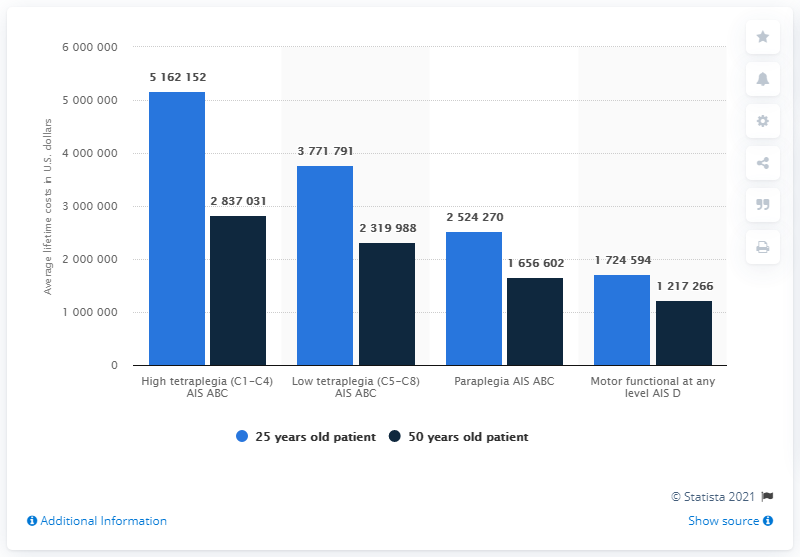Draw attention to some important aspects in this diagram. The estimated lifetime cost for a 25-year-old patient with paraplegia in the United States is approximately 252,427,000. 